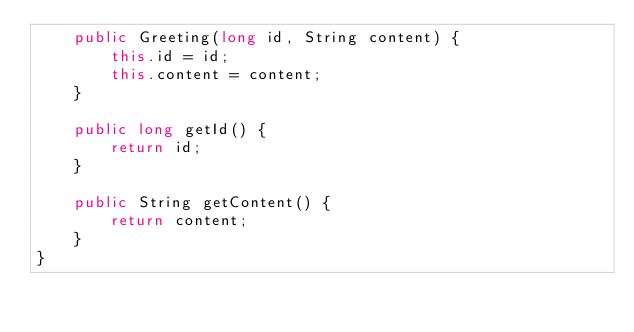Convert code to text. <code><loc_0><loc_0><loc_500><loc_500><_Java_>    public Greeting(long id, String content) {
        this.id = id;
        this.content = content;
    }

    public long getId() {
        return id;
    }

    public String getContent() {
        return content;
    }
}
</code> 